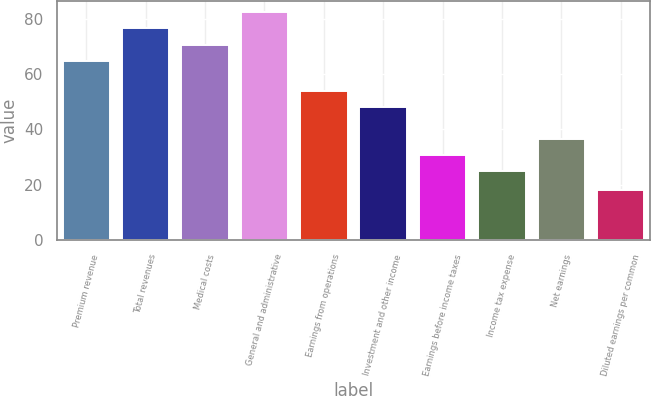<chart> <loc_0><loc_0><loc_500><loc_500><bar_chart><fcel>Premium revenue<fcel>Total revenues<fcel>Medical costs<fcel>General and administrative<fcel>Earnings from operations<fcel>Investment and other income<fcel>Earnings before income taxes<fcel>Income tax expense<fcel>Net earnings<fcel>Diluted earnings per common<nl><fcel>64.8<fcel>76.46<fcel>70.63<fcel>82.29<fcel>53.73<fcel>47.9<fcel>30.63<fcel>24.8<fcel>36.46<fcel>18<nl></chart> 